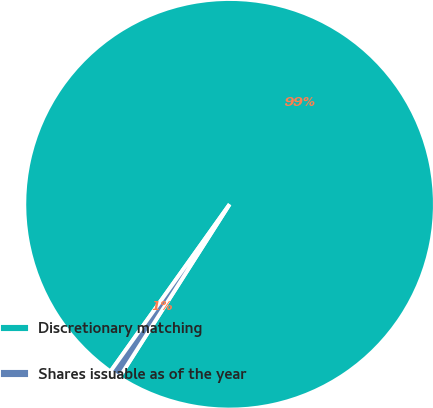<chart> <loc_0><loc_0><loc_500><loc_500><pie_chart><fcel>Discretionary matching<fcel>Shares issuable as of the year<nl><fcel>99.17%<fcel>0.83%<nl></chart> 